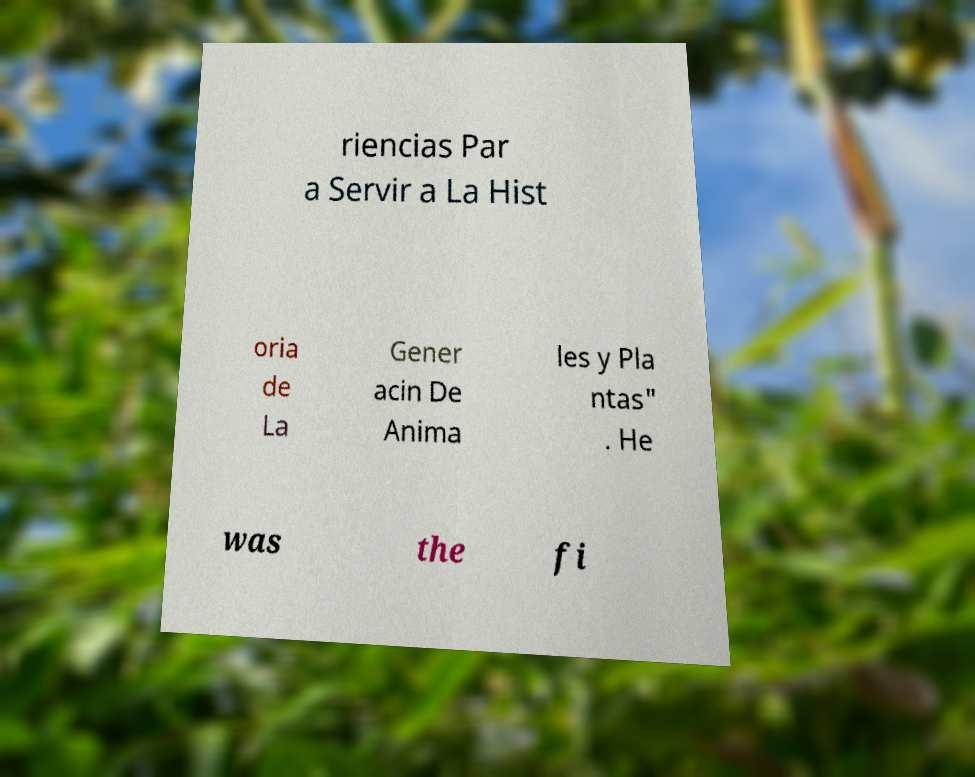Can you read and provide the text displayed in the image?This photo seems to have some interesting text. Can you extract and type it out for me? riencias Par a Servir a La Hist oria de La Gener acin De Anima les y Pla ntas" . He was the fi 